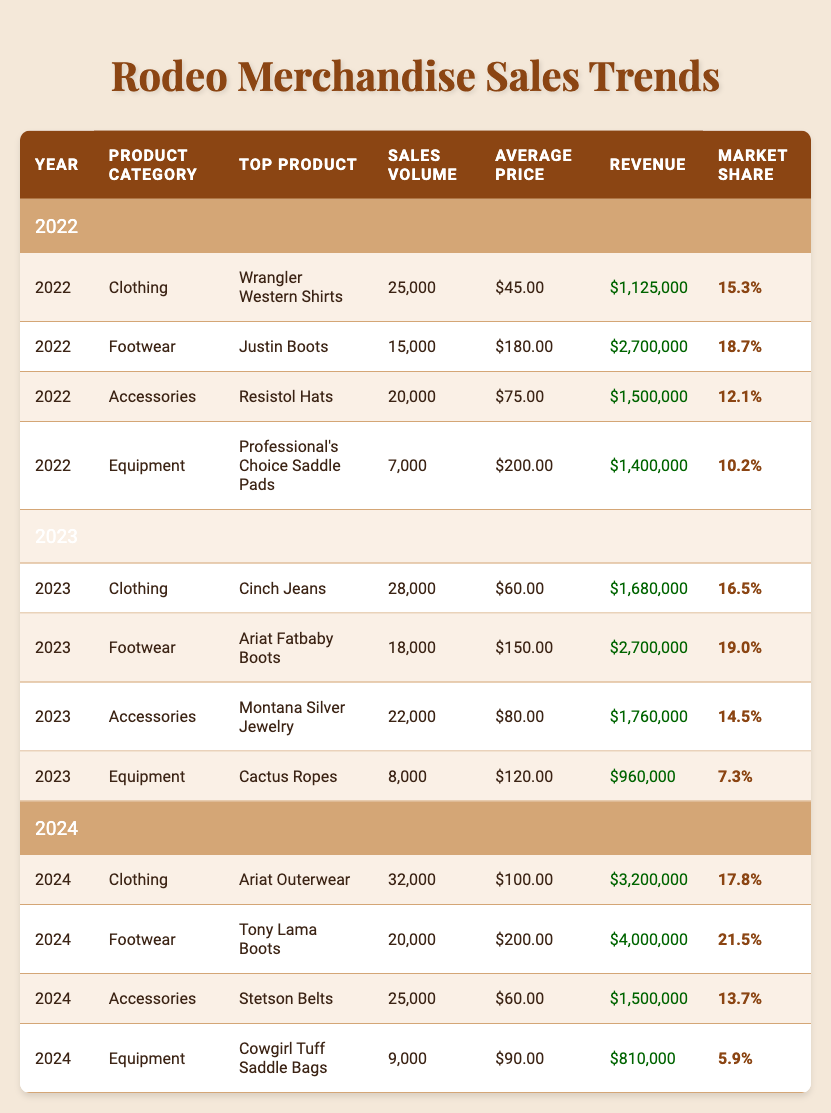What was the top-selling accessory in 2022? The table indicates that Resistol Hats were the top-selling accessory in 2022, with a sales volume of 20,000 units.
Answer: Resistol Hats Which product category had the highest revenue in 2024? In the table, Footwear, with Tony Lama Boots at $4,000,000 in revenue, shows the highest revenue in 2024 compared to other categories.
Answer: Footwear What is the average price of clothing sold in 2023? The average prices for clothing products in 2023 are Cinch Jeans at $60.00. There is only one clothing entry, so the average price remains $60.00.
Answer: $60.00 Did the market share of Footwear increase from 2022 to 2023? In 2022, the market share for Footwear was 18.7%, and in 2023 it increased to 19.0%. Therefore, it is true that the market share for Footwear increased.
Answer: Yes What was the total revenue from all accessory sales in 2022 and 2023? For 2022, revenue from accessories (Resistol Hats) was $1,500,000, and for 2023 (Montana Silver Jewelry) it was $1,760,000. Summing these gives $1,500,000 + $1,760,000 = $3,260,000.
Answer: $3,260,000 Which year had the highest sales volume for clothing? Looking at the sales volume for clothing across the years, 2024 had the highest sales volume of 32,000 compared to 28,000 in 2023 and 25,000 in 2022.
Answer: 2024 How much did the sales volume of Equipment change from 2022 to 2023? The sales volume for Equipment was 7,000 in 2022 and increased to 8,000 in 2023. The difference is 8,000 - 7,000 = 1,000 units.
Answer: Increased by 1,000 units What percentage increase in market share did Clothing experience from 2022 to 2024? Clothing's market share in 2022 was 15.3% and in 2024 it was 17.8%. The increase = 17.8% - 15.3% = 2.5%. To find the percentage increase: (2.5 / 15.3) * 100 ≈ 16.34%.
Answer: Approximately 16.34% Was the average price of Equipment in 2024 higher than in 2022? The average price of Equipment in 2022 was $200.00 for Professional's Choice Saddle Pads, and in 2024, it was $90.00 for Cowgirl Tuff Saddle Bags. Thus, it is false that the average price in 2024 was higher.
Answer: No 